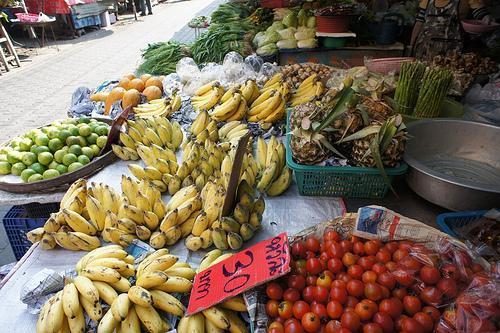How many fruits are showing in the photo?
Give a very brief answer. 5. How many yellow produce items are for sale at this market?
Give a very brief answer. 3. 